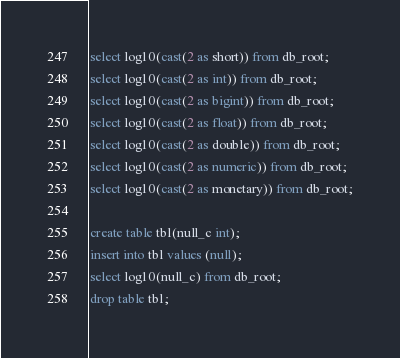Convert code to text. <code><loc_0><loc_0><loc_500><loc_500><_SQL_>select log10(cast(2 as short)) from db_root;
select log10(cast(2 as int)) from db_root;
select log10(cast(2 as bigint)) from db_root;
select log10(cast(2 as float)) from db_root;
select log10(cast(2 as double)) from db_root;
select log10(cast(2 as numeric)) from db_root;
select log10(cast(2 as monetary)) from db_root;

create table tbl(null_c int);
insert into tbl values (null);
select log10(null_c) from db_root;
drop table tbl;
</code> 